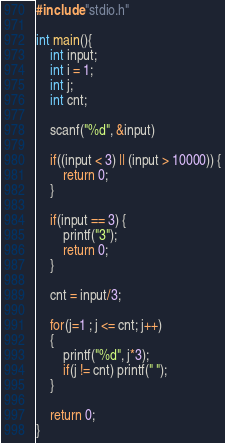<code> <loc_0><loc_0><loc_500><loc_500><_C_>#include "stdio.h"

int main(){
    int input;
    int i = 1;
    int j;
    int cnt;

    scanf("%d", &input)

    if((input < 3) || (input > 10000)) {
        return 0;
    }

    if(input == 3) {
        printf("3");
        return 0;
    }

    cnt = input/3;

    for(j=1 ; j <= cnt; j++)
    {
        printf("%d", j*3);
        if(j != cnt) printf(" ");
    }

    return 0;
}
</code> 